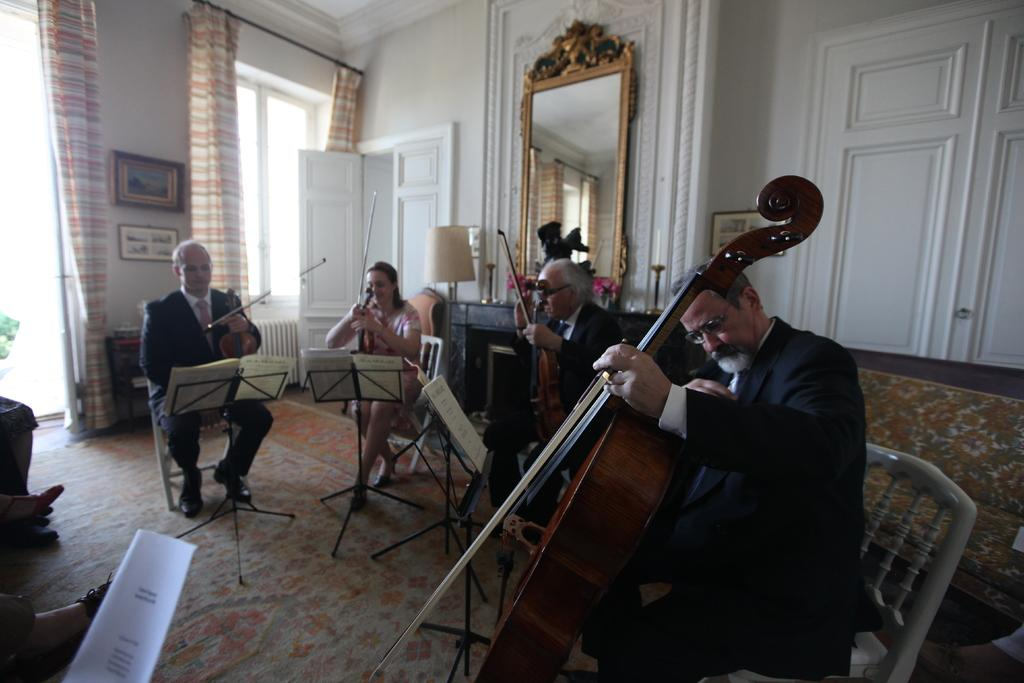Who is present in the image? There are people in the image. What are the people doing in the image? The people are sitting. What objects are the people holding in their hands? The people are holding a violin in their hands. How many brothers are sitting together in the image? There is no mention of brothers in the image, and the number of people present is not specified. 